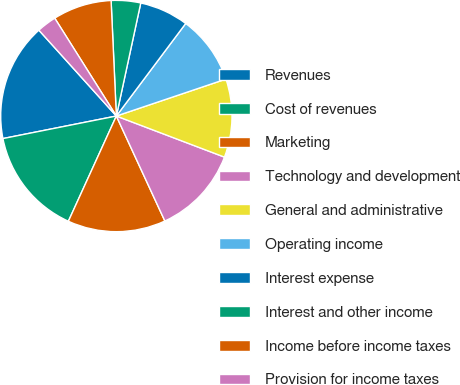Convert chart. <chart><loc_0><loc_0><loc_500><loc_500><pie_chart><fcel>Revenues<fcel>Cost of revenues<fcel>Marketing<fcel>Technology and development<fcel>General and administrative<fcel>Operating income<fcel>Interest expense<fcel>Interest and other income<fcel>Income before income taxes<fcel>Provision for income taxes<nl><fcel>16.44%<fcel>15.07%<fcel>13.7%<fcel>12.33%<fcel>10.96%<fcel>9.59%<fcel>6.85%<fcel>4.11%<fcel>8.22%<fcel>2.74%<nl></chart> 